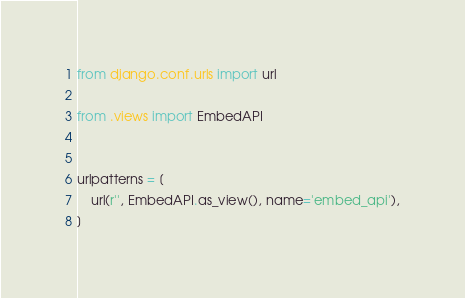Convert code to text. <code><loc_0><loc_0><loc_500><loc_500><_Python_>from django.conf.urls import url

from .views import EmbedAPI


urlpatterns = [
    url(r'', EmbedAPI.as_view(), name='embed_api'),
]
</code> 